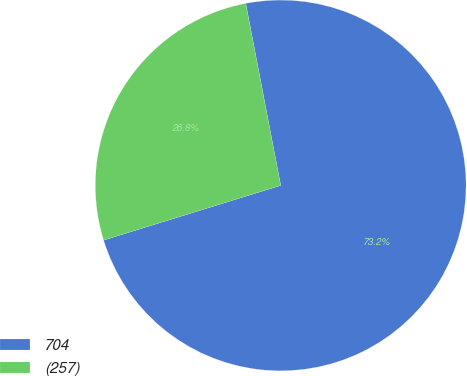Convert chart. <chart><loc_0><loc_0><loc_500><loc_500><pie_chart><fcel>704<fcel>(257)<nl><fcel>73.25%<fcel>26.75%<nl></chart> 